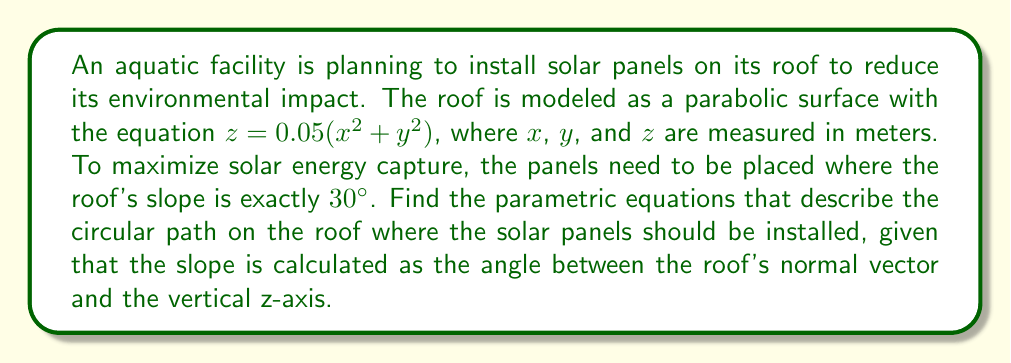What is the answer to this math problem? Let's approach this step-by-step:

1) First, we need to find the normal vector to the roof surface. We can do this by calculating the gradient of the surface:

   $\nabla z = (0.1x, 0.1y, -1)$

2) The normal vector $\vec{n}$ is therefore:

   $\vec{n} = (0.1x, 0.1y, 1)$

3) The angle $\theta$ between this normal vector and the z-axis (0, 0, 1) is given by:

   $\cos \theta = \frac{\vec{n} \cdot (0,0,1)}{|\vec{n}||(0,0,1)|} = \frac{1}{\sqrt{(0.1x)^2 + (0.1y)^2 + 1}}$

4) We want this angle to be 60° (complement of 30°), so:

   $\cos 60° = \frac{1}{\sqrt{(0.1x)^2 + (0.1y)^2 + 1}}$

5) Solving this equation:

   $\frac{1}{2} = \frac{1}{\sqrt{(0.1x)^2 + (0.1y)^2 + 1}}$
   $(0.1x)^2 + (0.1y)^2 = 3$
   $x^2 + y^2 = 300$

6) This is the equation of a circle with radius $\sqrt{300} = 10\sqrt{3}$ meters.

7) We can parameterize this circle using the parameter $t$:

   $x = 10\sqrt{3} \cos t$
   $y = 10\sqrt{3} \sin t$
   $z = 0.05(x^2 + y^2) = 0.05(300) = 15$

   Where $0 \leq t < 2\pi$

Therefore, the parametric equations describing the path for optimal solar panel placement are:

$$
\begin{cases}
x = 10\sqrt{3} \cos t \\
y = 10\sqrt{3} \sin t \\
z = 15
\end{cases}
$$

Where $0 \leq t < 2\pi$
Answer: The parametric equations for the optimal solar panel placement are:

$$
\begin{cases}
x = 10\sqrt{3} \cos t \\
y = 10\sqrt{3} \sin t \\
z = 15
\end{cases}
$$

Where $0 \leq t < 2\pi$ 